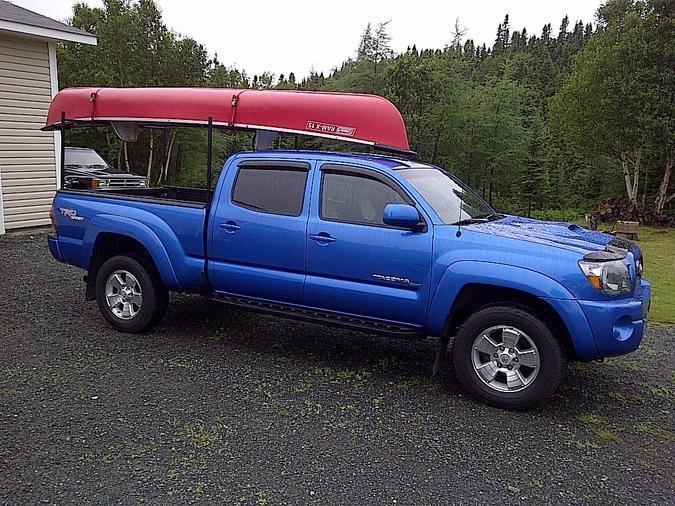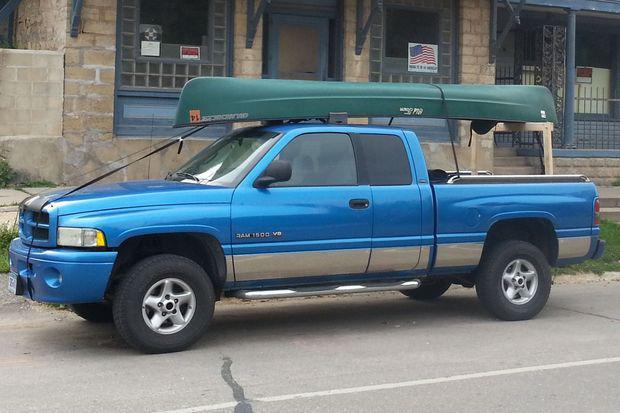The first image is the image on the left, the second image is the image on the right. Given the left and right images, does the statement "In one image, a canoe is strapped to the top of a blue pickup truck with wide silver trim on the lower panel." hold true? Answer yes or no. Yes. 